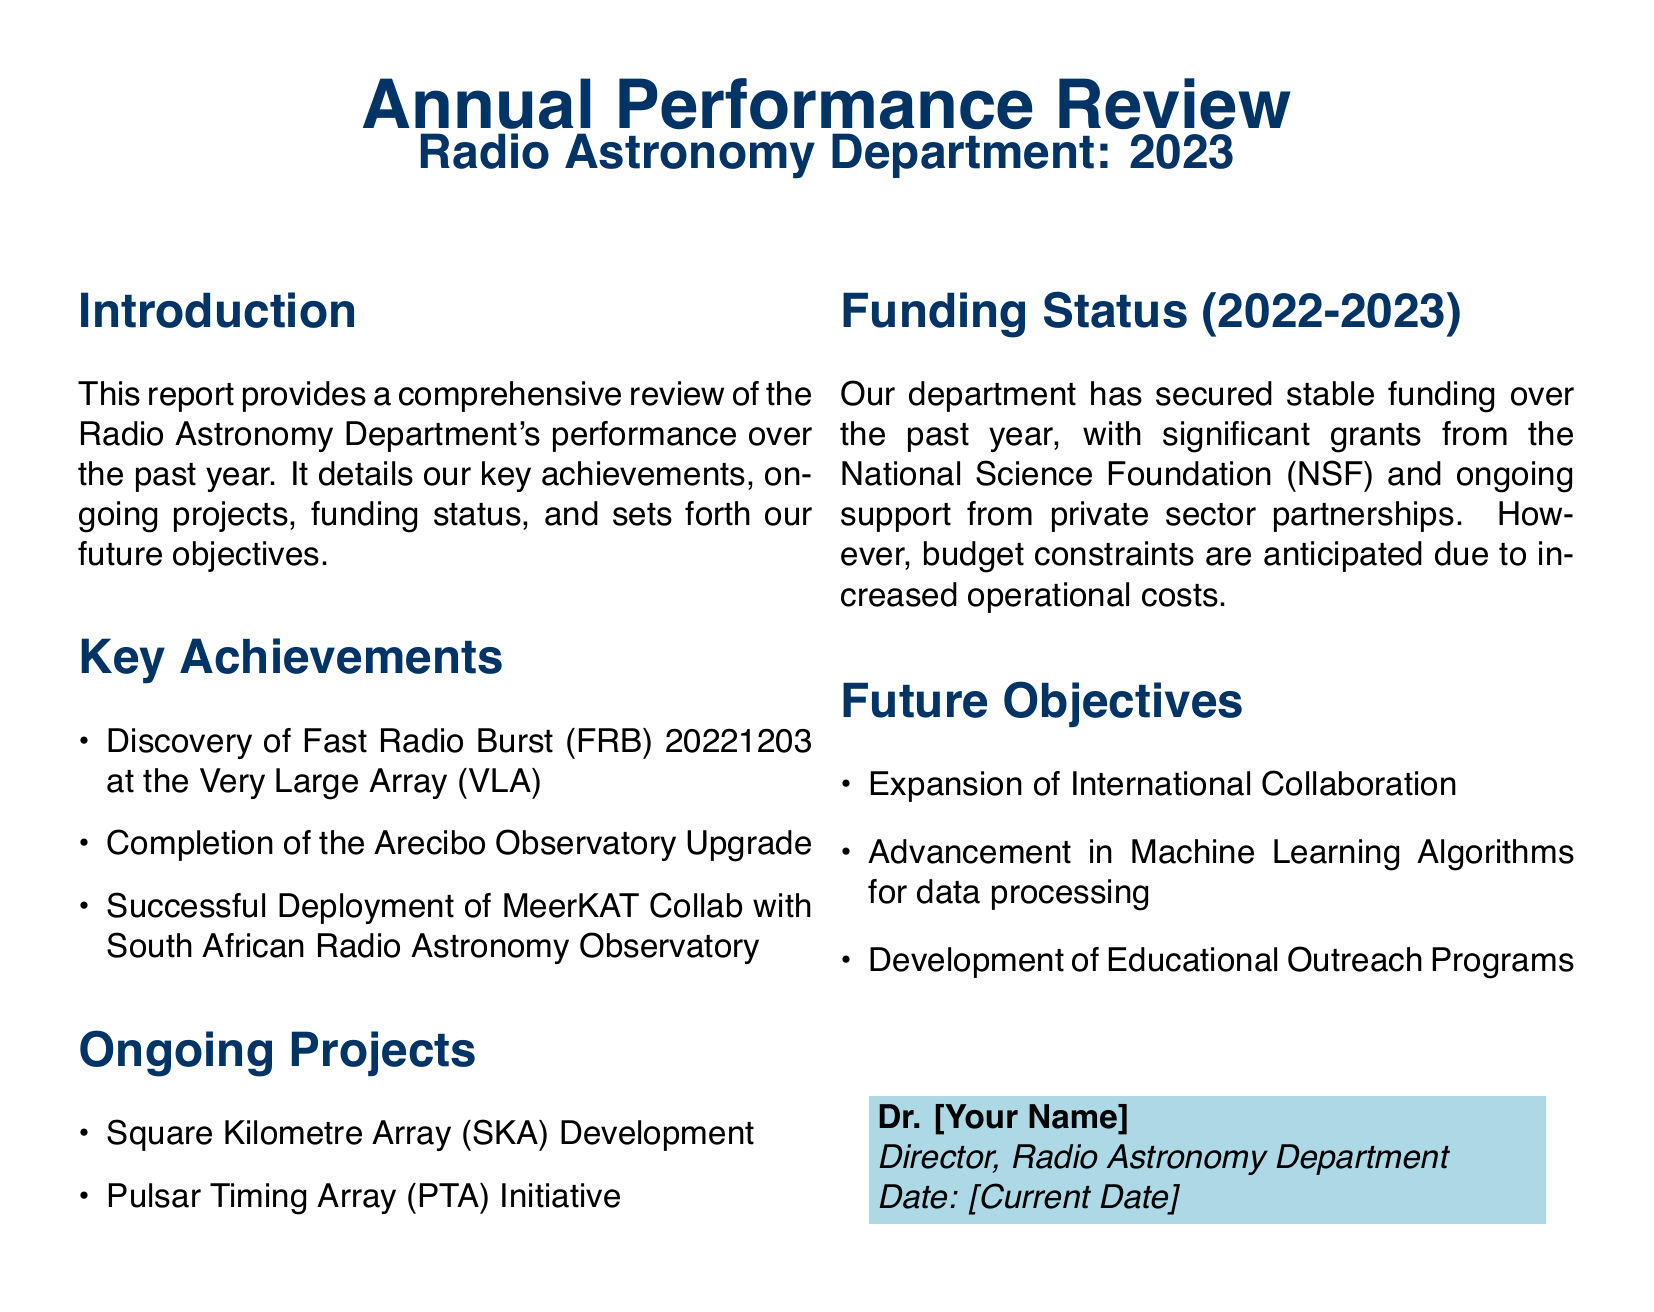What major discovery was made at the Very Large Array? The document mentions that the discovery of Fast Radio Burst (FRB) 20221203 was made at the Very Large Array.
Answer: Fast Radio Burst (FRB) 20221203 What project is ongoing related to pulsars? The report states that the Pulsar Timing Array (PTA) Initiative is an ongoing project.
Answer: Pulsar Timing Array (PTA) Initiative What significant upgrade was completed this year? The completion of the Arecibo Observatory Upgrade is listed as a key achievement in the document.
Answer: Arecibo Observatory Upgrade Which organization provided significant grants to the department? The National Science Foundation (NSF) is mentioned as a source of significant grants.
Answer: National Science Foundation (NSF) What is one of the future objectives of the Radio Astronomy Department? One future objective mentioned is the expansion of international collaboration.
Answer: Expansion of International Collaboration How many ongoing projects are listed in the document? The document lists two ongoing projects: the Square Kilometre Array (SKA) Development and the Pulsar Timing Array (PTA) Initiative.
Answer: Two What color is used for the report's title? The title is formatted with the color dark blue according to the document.
Answer: Dark blue What is the anticipated situation regarding funding in the coming year? The document mentions that budget constraints are anticipated due to increased operational costs.
Answer: Budget constraints 